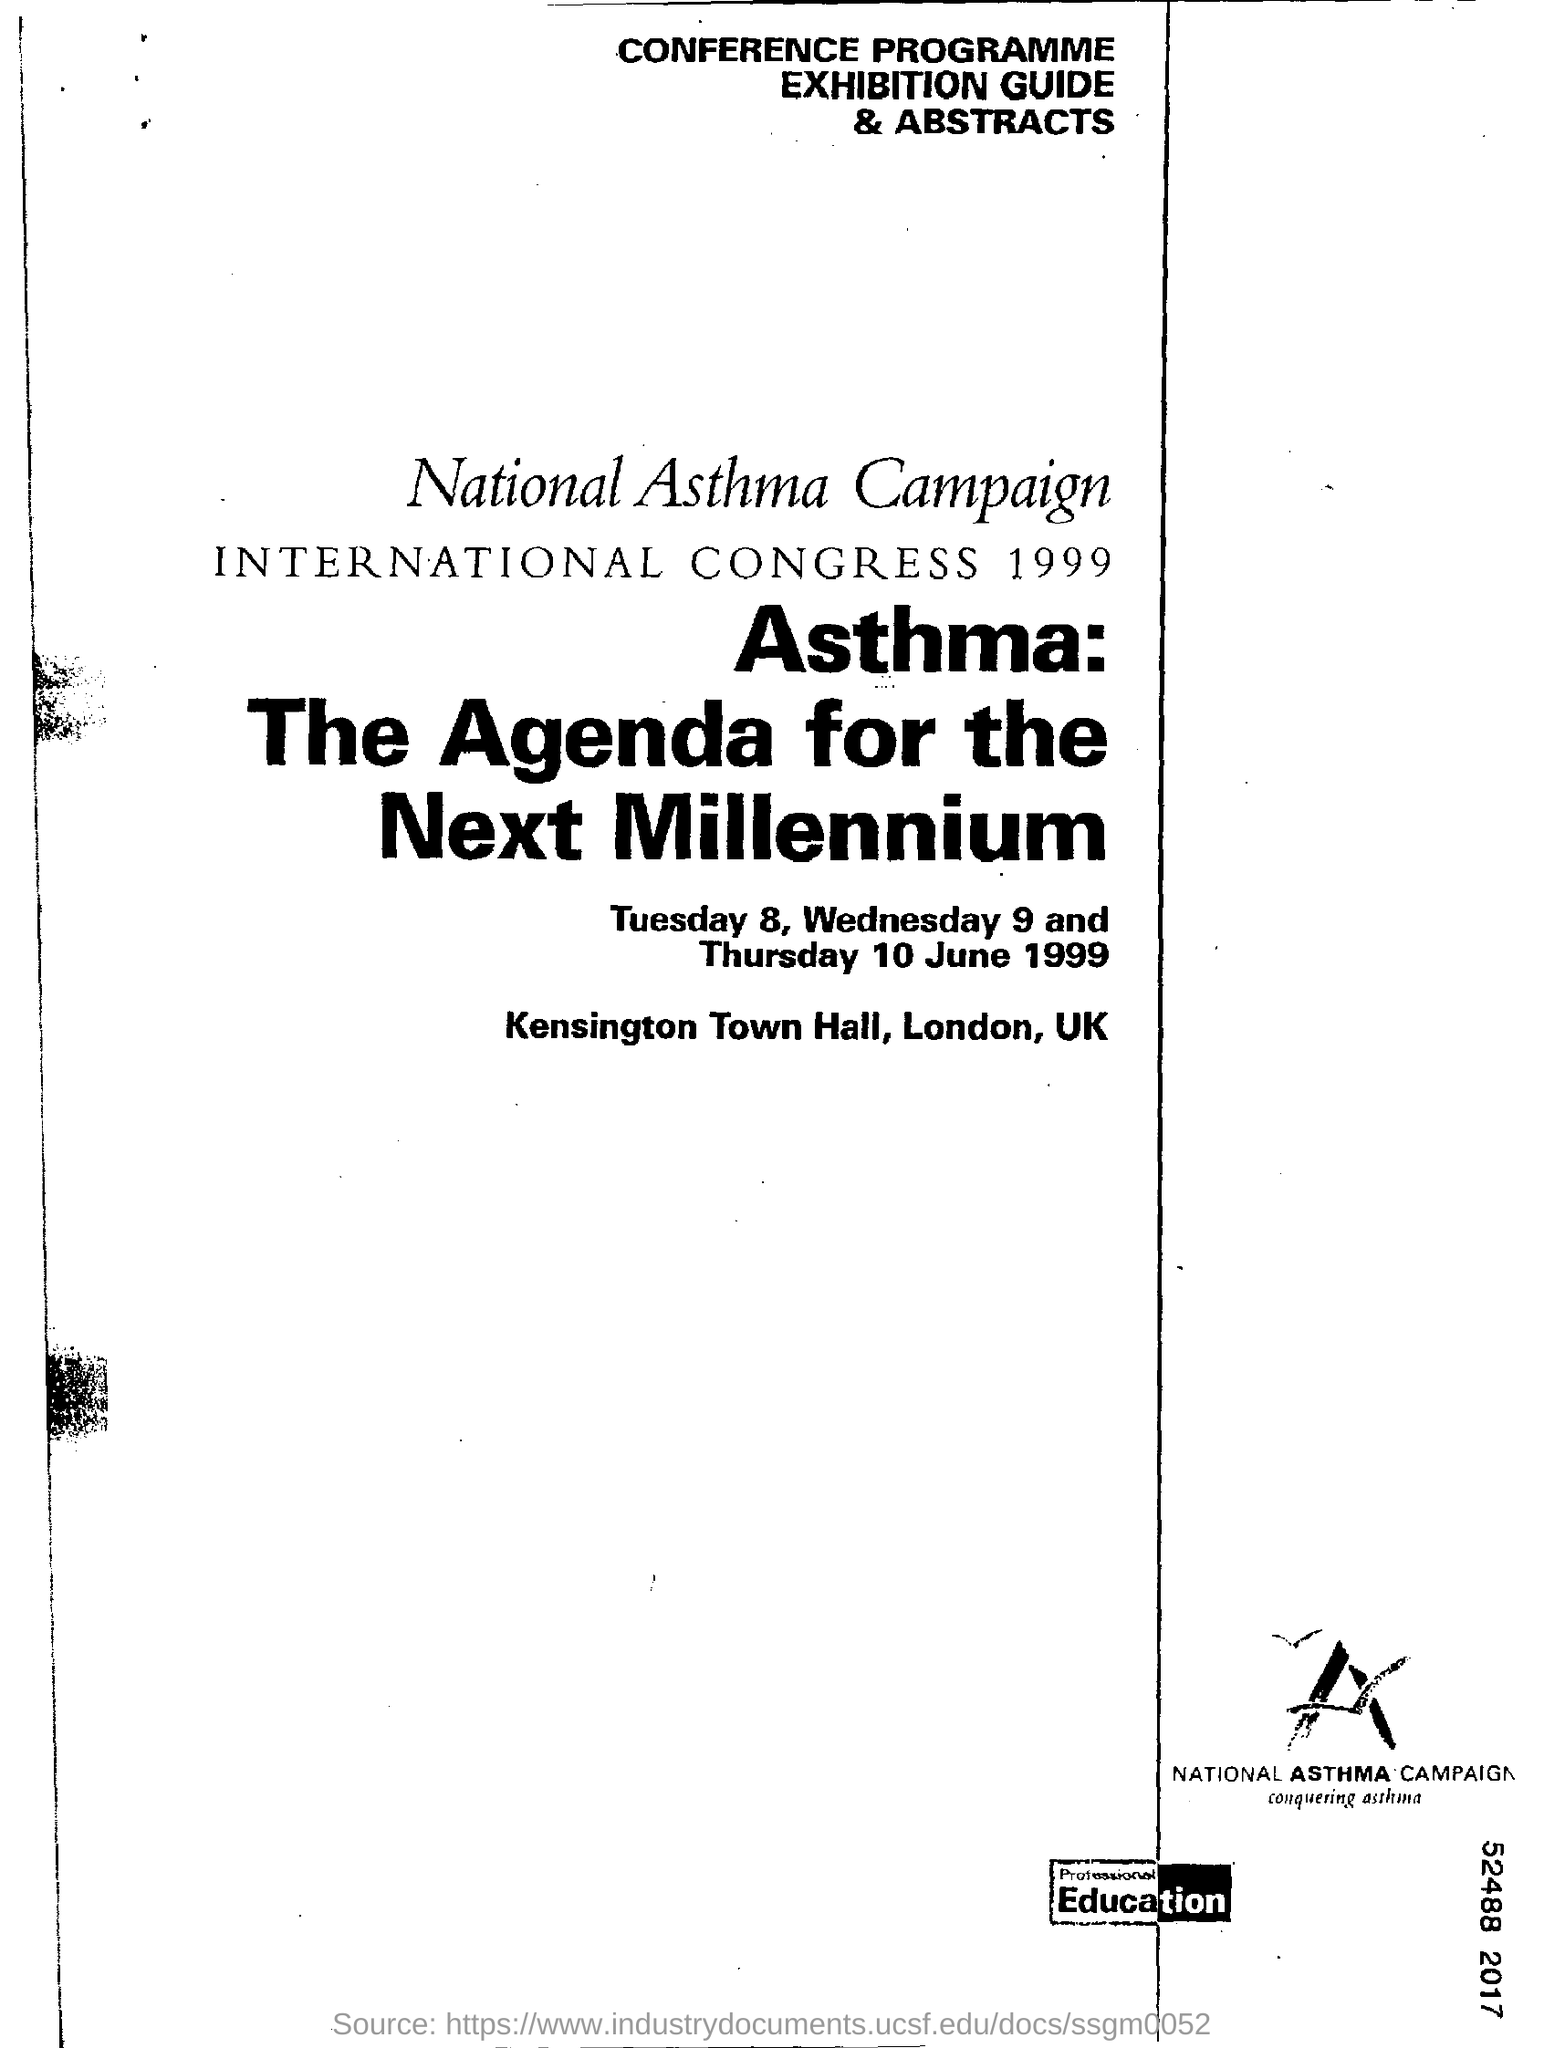Which year National Asthma Campaign conducted?
Offer a very short reply. 1999. Where was the international Congress 1999 held on?
Ensure brevity in your answer.  Kensington Town Hall, London, UK. 